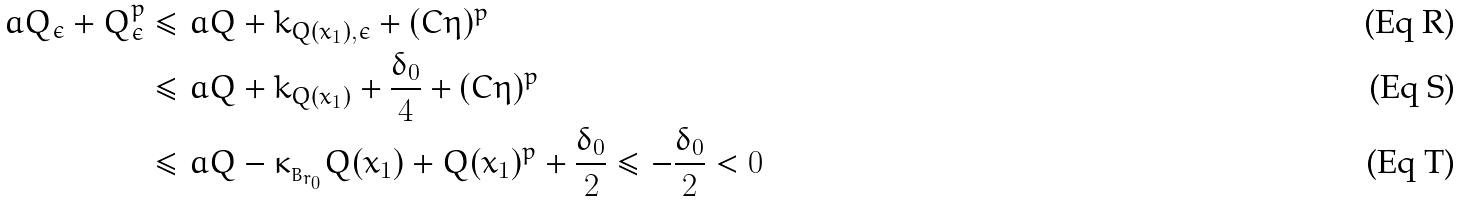Convert formula to latex. <formula><loc_0><loc_0><loc_500><loc_500>\L a Q _ { \epsilon } + Q ^ { p } _ { \epsilon } & \leq \L a Q + k _ { Q ( x _ { 1 } ) , \epsilon } + ( C \eta ) ^ { p } \\ & \leq \L a Q + k _ { Q ( x _ { 1 } ) } + \frac { \delta _ { 0 } } { 4 } + ( C \eta ) ^ { p } \\ & \leq \L a Q - \kappa _ { _ { B _ { r _ { 0 } } } } Q ( x _ { 1 } ) + Q ( x _ { 1 } ) ^ { p } + \frac { \delta _ { 0 } } { 2 } \leq - \frac { \delta _ { 0 } } { 2 } < 0</formula> 